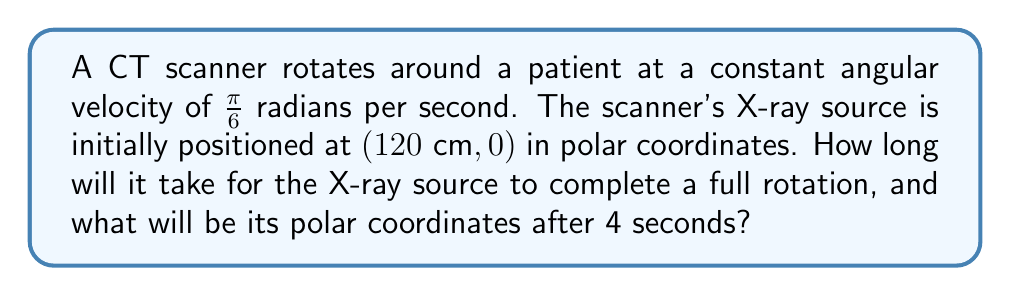Provide a solution to this math problem. Let's approach this problem step-by-step:

1) First, let's calculate the time for a full rotation:
   - A full rotation is $2\pi$ radians
   - The angular velocity is $\frac{\pi}{6}$ radians per second
   - Time for full rotation = $\frac{2\pi}{\frac{\pi}{6}} = 12$ seconds

2) Now, let's determine the position after 4 seconds:
   - The initial position is $(120\text{ cm}, 0°)$
   - In 4 seconds, the scanner will rotate by:
     $4 \cdot \frac{\pi}{6} = \frac{2\pi}{3}$ radians
   - $\frac{2\pi}{3}$ radians = $120°$

3) The radial distance remains constant at 120 cm, only the angle changes.

4) Therefore, after 4 seconds, the polar coordinates will be $(120\text{ cm}, 120°)$

To express this in the standard polar coordinate notation $(r, \theta)$:
$$(120, \frac{2\pi}{3})$$

Where $r = 120$ cm and $\theta = \frac{2\pi}{3}$ radians.
Answer: Time for full rotation: 12 seconds
Polar coordinates after 4 seconds: $(120, \frac{2\pi}{3})$ or $(120\text{ cm}, 120°)$ 